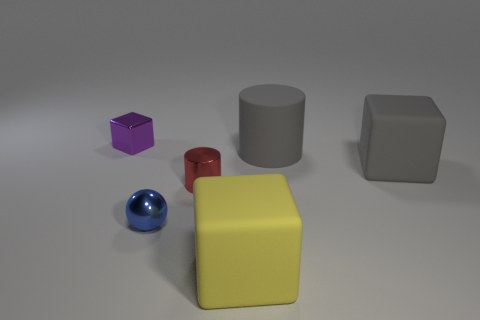Are there any small metallic things that have the same color as the rubber cylinder?
Keep it short and to the point. No. There is a big cube that is in front of the red cylinder; is there a object that is left of it?
Offer a terse response. Yes. There is a gray block; is its size the same as the cylinder that is on the left side of the big yellow cube?
Your answer should be very brief. No. Is there a tiny purple shiny object that is on the left side of the matte cube that is right of the cube that is in front of the gray rubber block?
Make the answer very short. Yes. There is a big cube that is right of the large cylinder; what is its material?
Provide a short and direct response. Rubber. Does the yellow matte thing have the same size as the matte cylinder?
Your answer should be very brief. Yes. What color is the rubber object that is behind the blue object and in front of the gray cylinder?
Make the answer very short. Gray. What shape is the tiny blue thing that is made of the same material as the tiny red thing?
Give a very brief answer. Sphere. What number of things are both left of the tiny shiny cylinder and in front of the small cylinder?
Keep it short and to the point. 1. There is a small purple metallic object; are there any big yellow matte things in front of it?
Keep it short and to the point. Yes. 